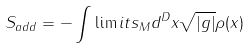Convert formula to latex. <formula><loc_0><loc_0><loc_500><loc_500>S _ { a d d } = - \int \lim i t s _ { M } d ^ { D } x \sqrt { | g | } \rho ( x )</formula> 